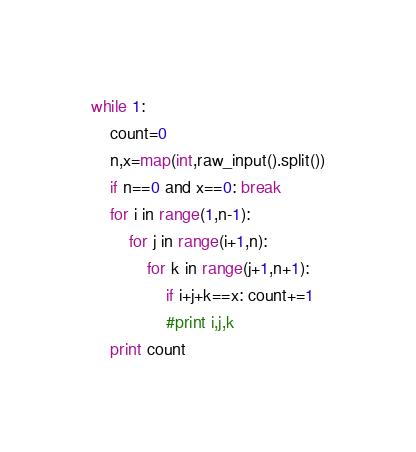Convert code to text. <code><loc_0><loc_0><loc_500><loc_500><_Python_>while 1:
	count=0
	n,x=map(int,raw_input().split())
	if n==0 and x==0: break
	for i in range(1,n-1):
		for j in range(i+1,n):
			for k in range(j+1,n+1):
				if i+j+k==x: count+=1
				#print i,j,k
	print count</code> 